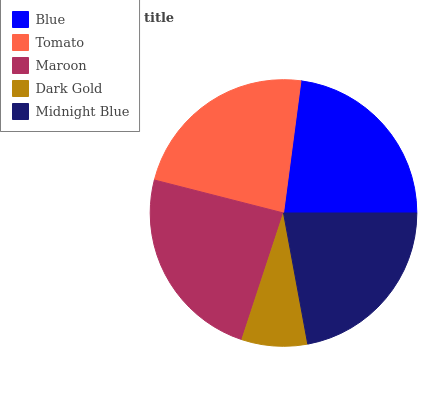Is Dark Gold the minimum?
Answer yes or no. Yes. Is Maroon the maximum?
Answer yes or no. Yes. Is Tomato the minimum?
Answer yes or no. No. Is Tomato the maximum?
Answer yes or no. No. Is Tomato greater than Blue?
Answer yes or no. Yes. Is Blue less than Tomato?
Answer yes or no. Yes. Is Blue greater than Tomato?
Answer yes or no. No. Is Tomato less than Blue?
Answer yes or no. No. Is Blue the high median?
Answer yes or no. Yes. Is Blue the low median?
Answer yes or no. Yes. Is Tomato the high median?
Answer yes or no. No. Is Dark Gold the low median?
Answer yes or no. No. 